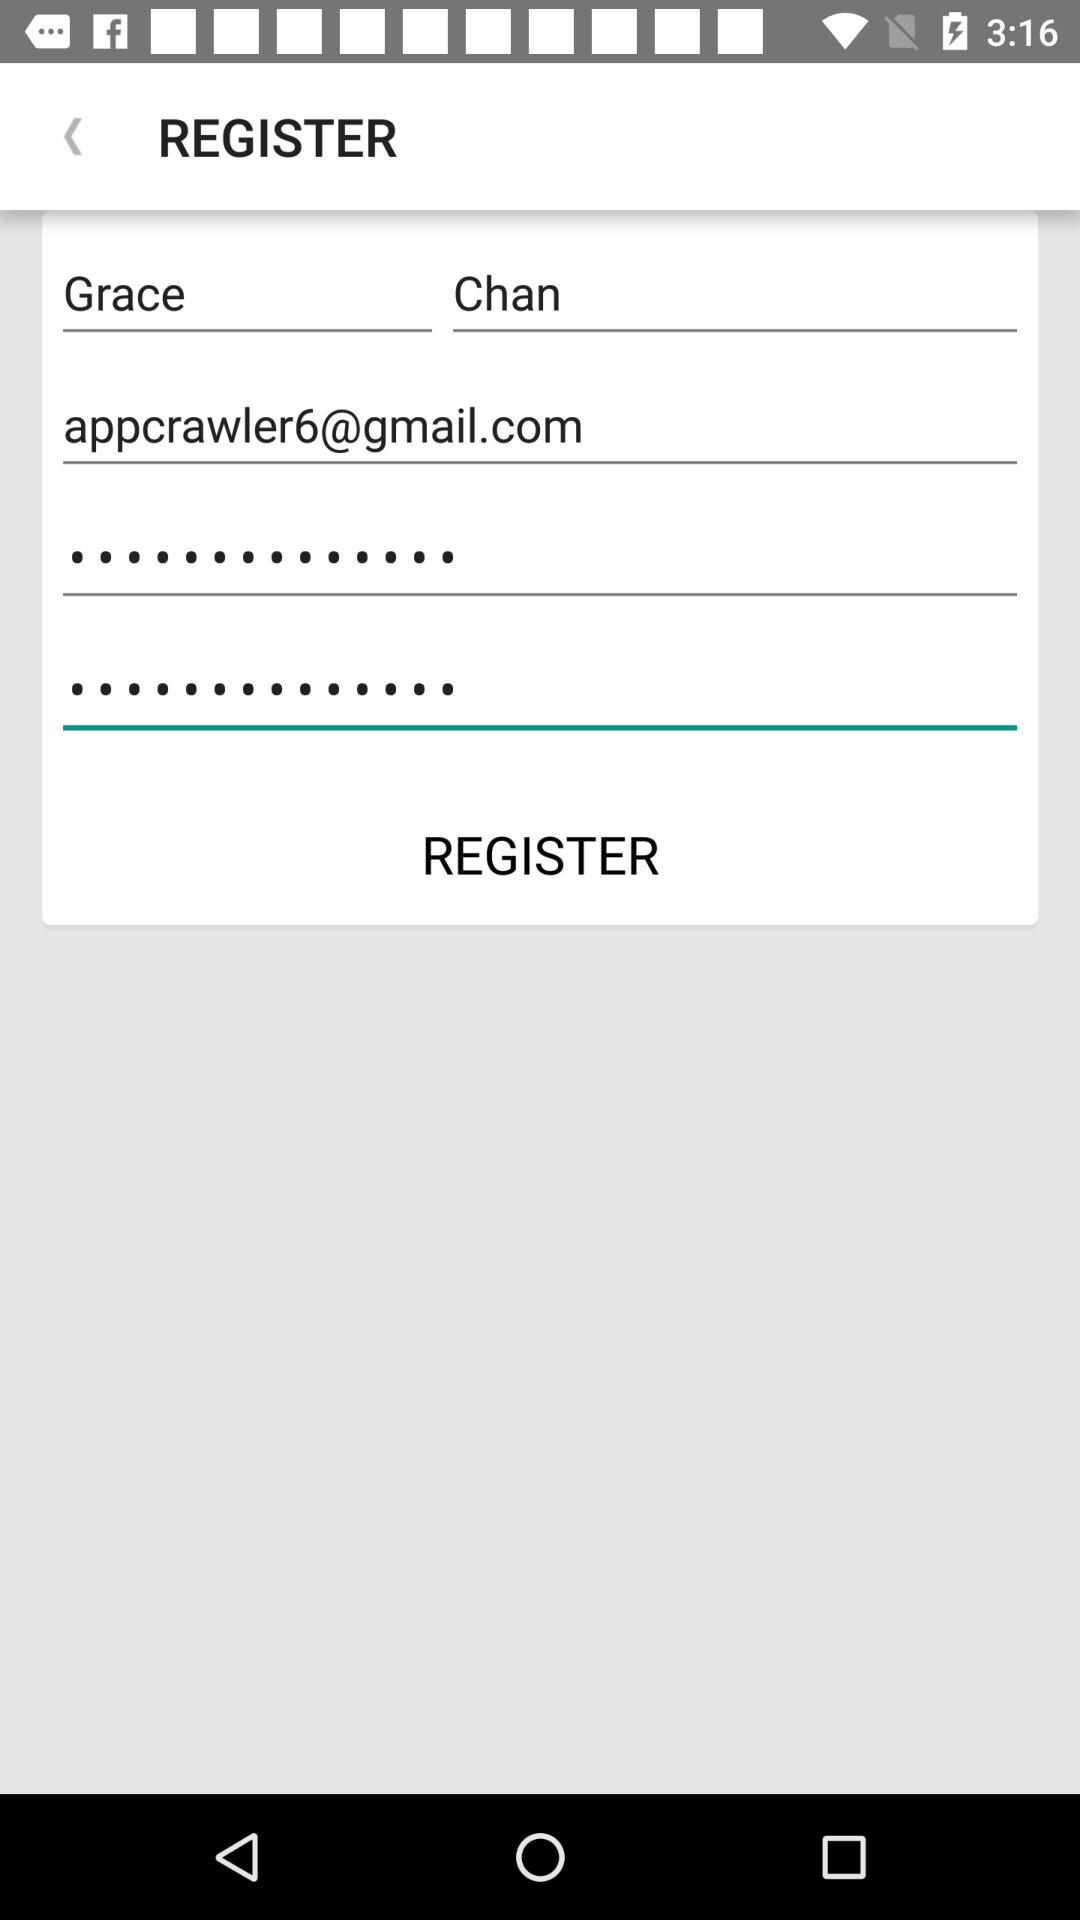How many text inputs are there that are not empty?
Answer the question using a single word or phrase. 3 